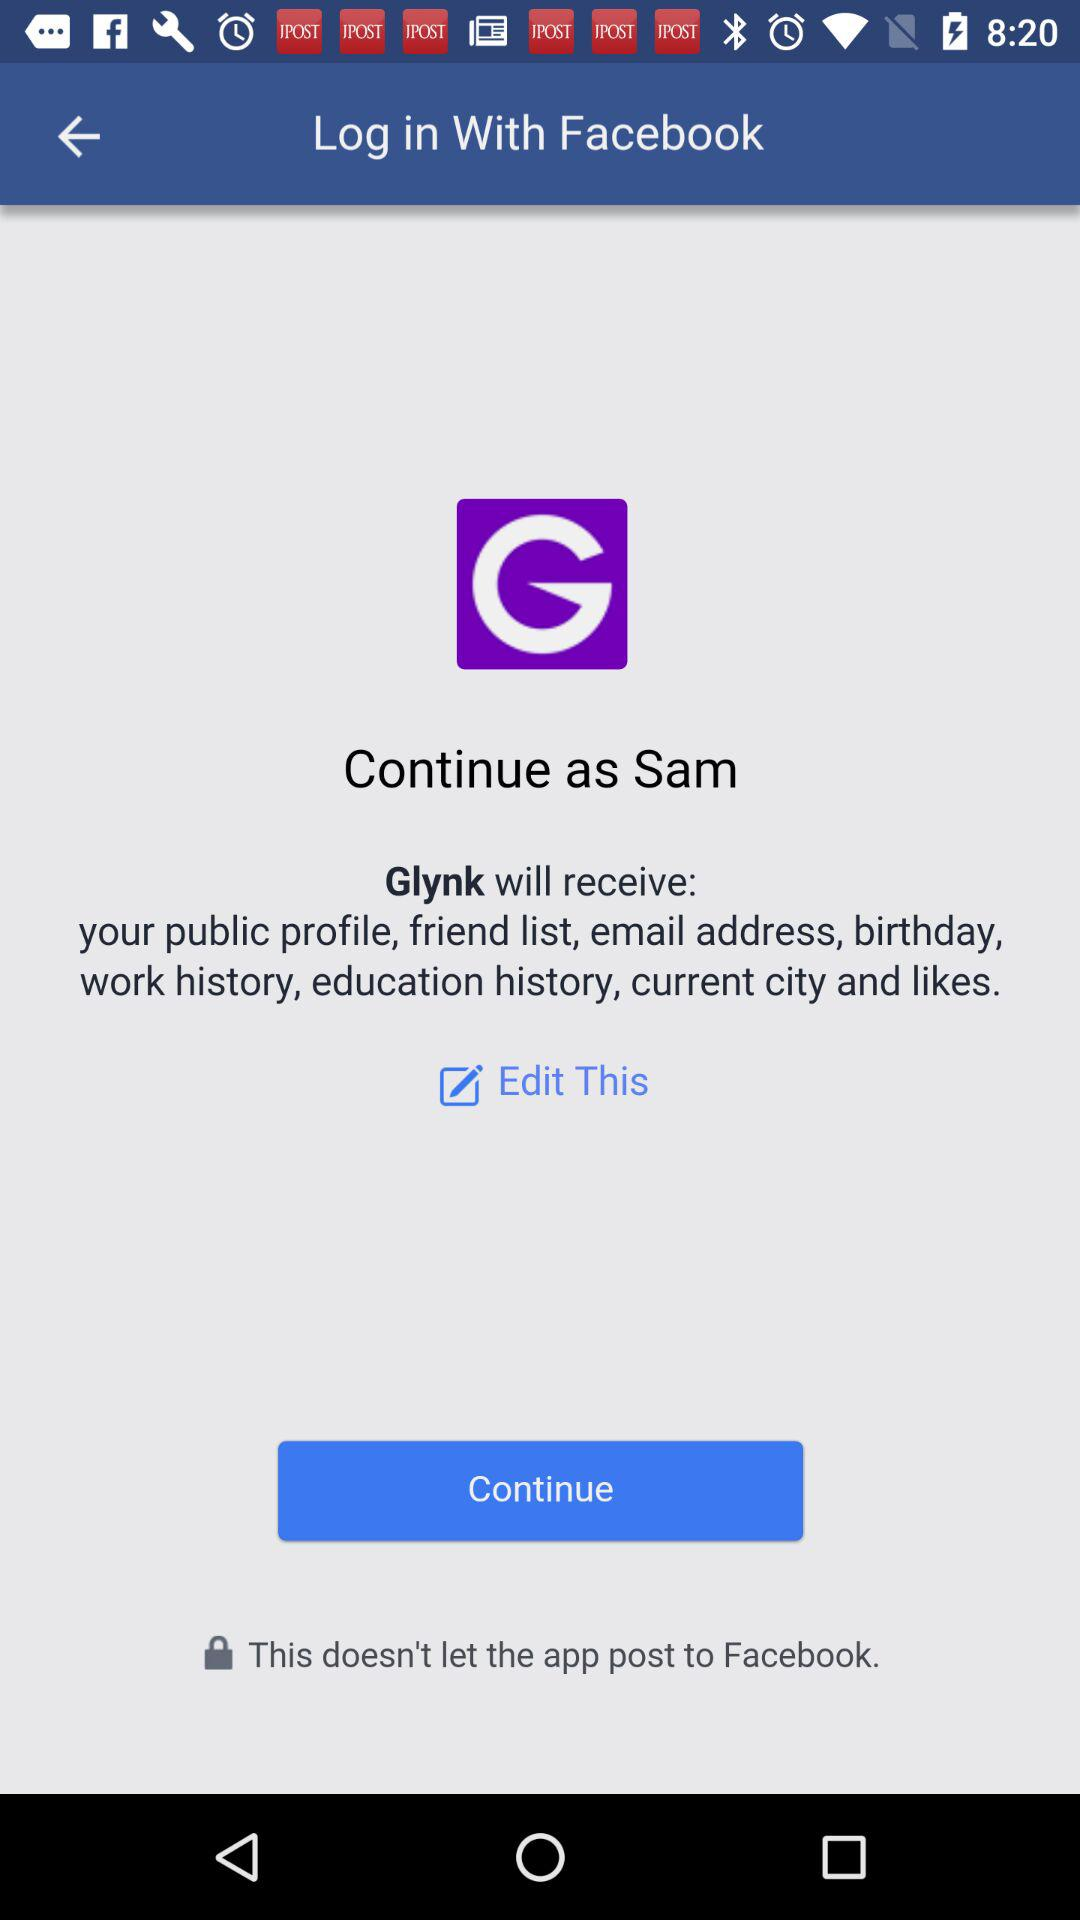What application is used for login? The application used for login is "Facebook". 